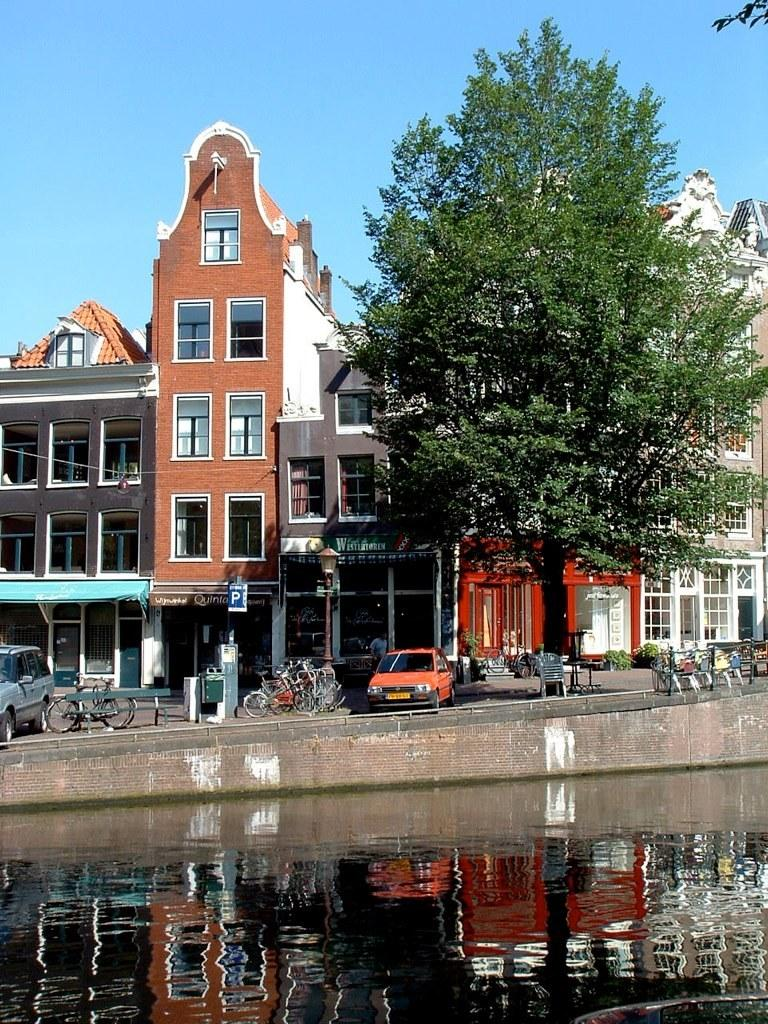What is the primary element visible in the image? There is water in the image. What type of natural element can be seen in the image? There is a tree and plants in the image. What type of man-made structures are present in the image? There are buildings in the image. What type of transportation is visible in the image? There are vehicles in the image. What type of signage is present in the image? There is a signboard in the image. What can be seen in the background of the image? The background of the image includes a blue sky. What type of lace can be seen hanging from the tree in the image? There is no lace present in the image; it features water, a tree, plants, buildings, vehicles, a signboard, and a blue sky in the background. Can you see a basketball court in the image? There is no basketball court visible in the image. 